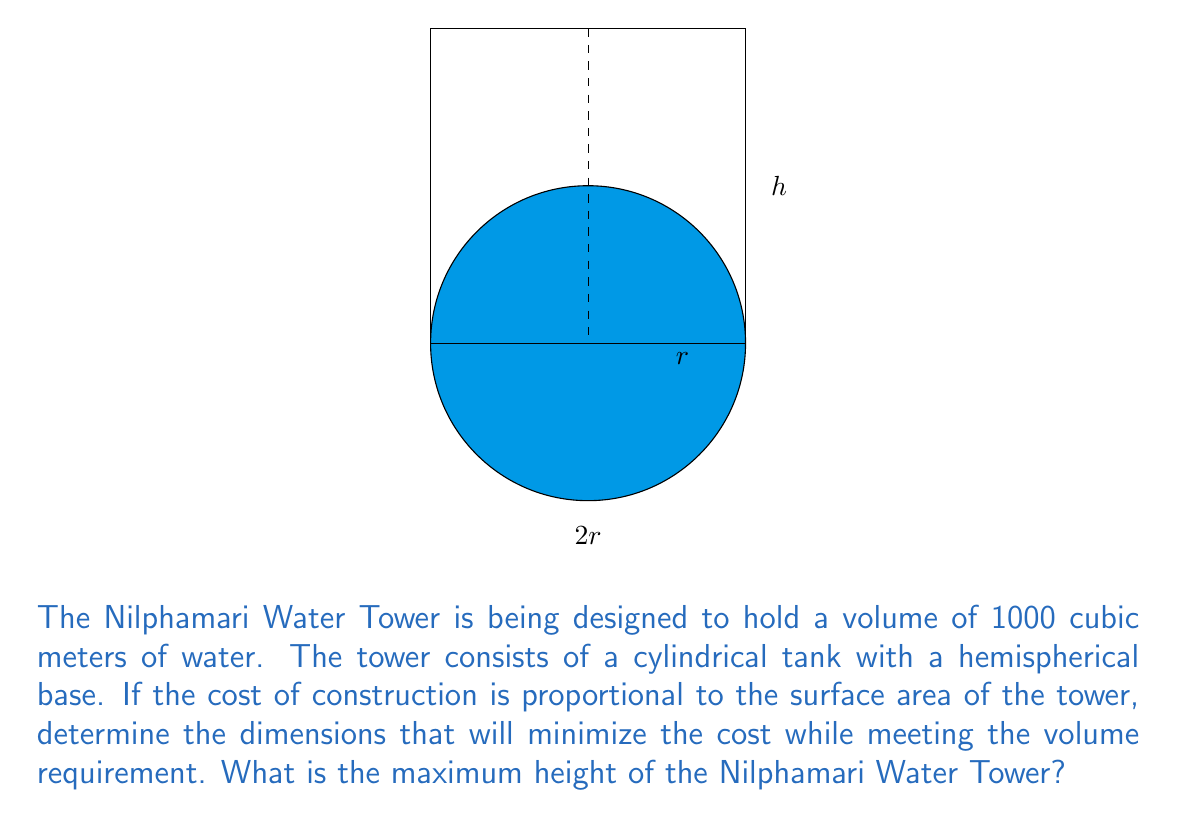Teach me how to tackle this problem. Let's approach this step-by-step:

1) Let $r$ be the radius of the cylinder and $h$ be the height of the cylindrical part.

2) The volume of the tower is the sum of the cylindrical part and the hemispherical base:

   $$V = \pi r^2 h + \frac{2}{3}\pi r^3 = 1000$$

3) The surface area (SA) of the tower is the sum of the lateral surface area of the cylinder and the surface area of the hemisphere:

   $$SA = 2\pi rh + 2\pi r^2$$

4) From the volume equation:

   $$\pi r^2 h + \frac{2}{3}\pi r^3 = 1000$$
   $$h = \frac{1000}{\pi r^2} - \frac{2r}{3}$$

5) Substitute this into the surface area equation:

   $$SA = 2\pi r(\frac{1000}{\pi r^2} - \frac{2r}{3}) + 2\pi r^2$$
   $$SA = \frac{2000}{r} - \frac{4\pi r^2}{3} + 2\pi r^2$$
   $$SA = \frac{2000}{r} + \frac{2\pi r^2}{3}$$

6) To minimize SA, we differentiate with respect to $r$ and set it to zero:

   $$\frac{dSA}{dr} = -\frac{2000}{r^2} + \frac{4\pi r}{3} = 0$$

7) Solve this equation:

   $$\frac{2000}{r^2} = \frac{4\pi r}{3}$$
   $$6000 = 4\pi r^3$$
   $$r^3 = \frac{1500}{\pi}$$
   $$r = \sqrt[3]{\frac{1500}{\pi}} \approx 7.14$$

8) Now we can find $h$:

   $$h = \frac{1000}{\pi r^2} - \frac{2r}{3} \approx 6.21$$

9) The total height of the tower is $h + 2r$:

   $$\text{Total Height} = 6.21 + 2(7.14) \approx 20.49$$
Answer: 20.49 meters 